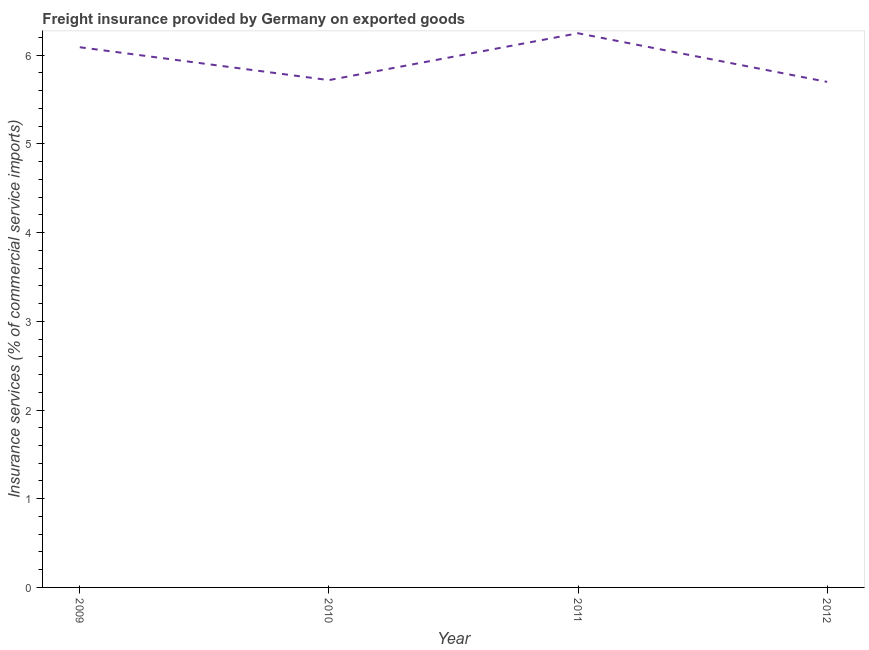What is the freight insurance in 2009?
Your answer should be compact. 6.09. Across all years, what is the maximum freight insurance?
Your answer should be very brief. 6.25. Across all years, what is the minimum freight insurance?
Your answer should be compact. 5.7. What is the sum of the freight insurance?
Give a very brief answer. 23.76. What is the difference between the freight insurance in 2010 and 2011?
Provide a short and direct response. -0.53. What is the average freight insurance per year?
Give a very brief answer. 5.94. What is the median freight insurance?
Your answer should be very brief. 5.9. Do a majority of the years between 2009 and 2012 (inclusive) have freight insurance greater than 2.6 %?
Offer a terse response. Yes. What is the ratio of the freight insurance in 2009 to that in 2012?
Provide a short and direct response. 1.07. Is the freight insurance in 2009 less than that in 2011?
Provide a short and direct response. Yes. Is the difference between the freight insurance in 2009 and 2011 greater than the difference between any two years?
Give a very brief answer. No. What is the difference between the highest and the second highest freight insurance?
Keep it short and to the point. 0.16. What is the difference between the highest and the lowest freight insurance?
Provide a short and direct response. 0.55. How many lines are there?
Provide a short and direct response. 1. How many years are there in the graph?
Your response must be concise. 4. What is the difference between two consecutive major ticks on the Y-axis?
Give a very brief answer. 1. What is the title of the graph?
Provide a succinct answer. Freight insurance provided by Germany on exported goods . What is the label or title of the X-axis?
Your answer should be compact. Year. What is the label or title of the Y-axis?
Provide a short and direct response. Insurance services (% of commercial service imports). What is the Insurance services (% of commercial service imports) of 2009?
Provide a short and direct response. 6.09. What is the Insurance services (% of commercial service imports) in 2010?
Provide a short and direct response. 5.72. What is the Insurance services (% of commercial service imports) in 2011?
Ensure brevity in your answer.  6.25. What is the Insurance services (% of commercial service imports) in 2012?
Give a very brief answer. 5.7. What is the difference between the Insurance services (% of commercial service imports) in 2009 and 2010?
Offer a very short reply. 0.37. What is the difference between the Insurance services (% of commercial service imports) in 2009 and 2011?
Ensure brevity in your answer.  -0.16. What is the difference between the Insurance services (% of commercial service imports) in 2009 and 2012?
Offer a terse response. 0.39. What is the difference between the Insurance services (% of commercial service imports) in 2010 and 2011?
Provide a succinct answer. -0.53. What is the difference between the Insurance services (% of commercial service imports) in 2010 and 2012?
Give a very brief answer. 0.02. What is the difference between the Insurance services (% of commercial service imports) in 2011 and 2012?
Provide a succinct answer. 0.55. What is the ratio of the Insurance services (% of commercial service imports) in 2009 to that in 2010?
Your answer should be very brief. 1.06. What is the ratio of the Insurance services (% of commercial service imports) in 2009 to that in 2012?
Offer a terse response. 1.07. What is the ratio of the Insurance services (% of commercial service imports) in 2010 to that in 2011?
Provide a succinct answer. 0.92. What is the ratio of the Insurance services (% of commercial service imports) in 2011 to that in 2012?
Ensure brevity in your answer.  1.1. 